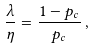Convert formula to latex. <formula><loc_0><loc_0><loc_500><loc_500>\frac { \lambda } { \eta } = \frac { 1 - p _ { c } } { p _ { c } } \, ,</formula> 